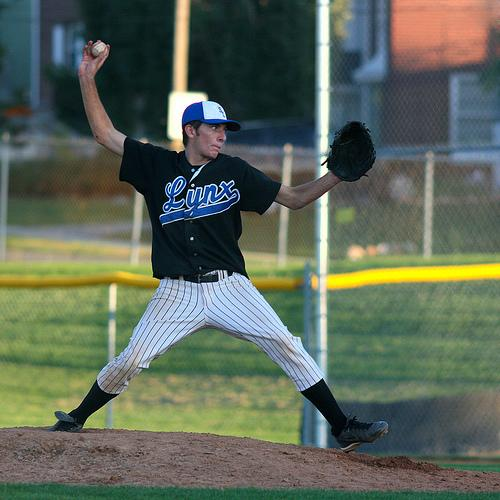What type of headwear is the man wearing in the image? A blue and white hat. Determine the sentiment evoked by the image based on the portrayed baseball game. The sentiment is excitement and anticipation as the pitcher throws the ball in action. Identify the main action performed by the baseball player in the image. A baseball pitcher in action, throwing a ball. Explain what the baseball pitcher is equipped with for this game. The pitcher is wearing a black and blue shirt, black and white striped pants, a blue and white hat, a black belt, black athletic shoes, and black socks. What type of field is this picture taking place in? A baseball field with brown dirt. Please find the big red balloon floating above the baseball player's head. There is no mention of a red balloon or any coordinates related to it in the given information. Moreover, balloons are not typically found in baseball games, and having a balloon floating above a player's head would be very unusual. Where is the ice cream stand that is usually present at the baseball games? This instruction is misleading because it discusses an ice cream stand, which is not mentioned anywhere in the provided information. The objects mentioned are directly related to baseball players and equipment, and an ice cream stand would be an additional object unrelated to the main scene. What type of sunglasses is the coach wearing in the image? This instruction is misleading because it refers to a coach, who is not mentioned in the provided information. Furthermore, there is no mention of sunglasses or their relevance. The objects listed in the image, primarily focus on baseball players and equipment, so discussing sunglasses and a coach is not appropriate for this image. Identify the small cat that can be seen sleeping beside the fence. There is no mention of any cat or its position in the given information. The objects mentioned are related to a baseball game, which is not usually related to cats. Furthermore, the presence of a cat would be very unusual on a baseball field. Can you locate the green umbrella in the top right corner of the image? This instruction is misleading because there is no mention of any green umbrella or its coordinates in the given information. Moreover, the objects mentioned are mostly related to a baseball game, and an umbrella is not typically associated with it. The American flag can be seen waving in the background - kindly point it out. No, it's not mentioned in the image. 